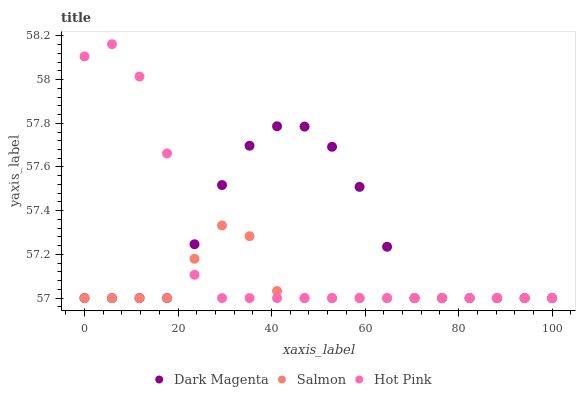Does Salmon have the minimum area under the curve?
Answer yes or no. Yes. Does Dark Magenta have the maximum area under the curve?
Answer yes or no. Yes. Does Dark Magenta have the minimum area under the curve?
Answer yes or no. No. Does Salmon have the maximum area under the curve?
Answer yes or no. No. Is Salmon the smoothest?
Answer yes or no. Yes. Is Hot Pink the roughest?
Answer yes or no. Yes. Is Dark Magenta the smoothest?
Answer yes or no. No. Is Dark Magenta the roughest?
Answer yes or no. No. Does Hot Pink have the lowest value?
Answer yes or no. Yes. Does Hot Pink have the highest value?
Answer yes or no. Yes. Does Dark Magenta have the highest value?
Answer yes or no. No. Does Hot Pink intersect Dark Magenta?
Answer yes or no. Yes. Is Hot Pink less than Dark Magenta?
Answer yes or no. No. Is Hot Pink greater than Dark Magenta?
Answer yes or no. No. 